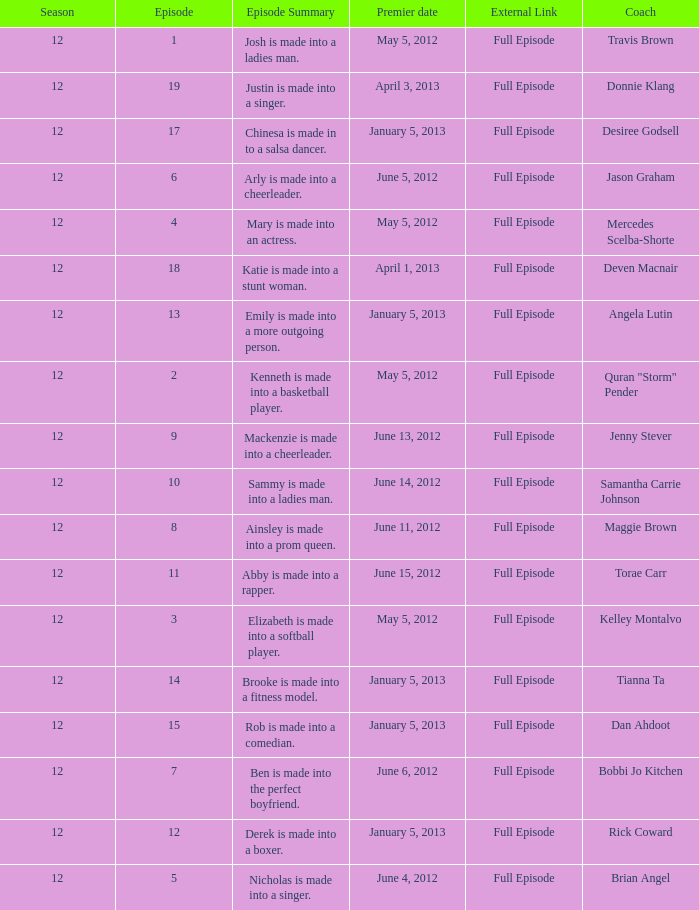Name the coach for  emily is made into a more outgoing person. Angela Lutin. 